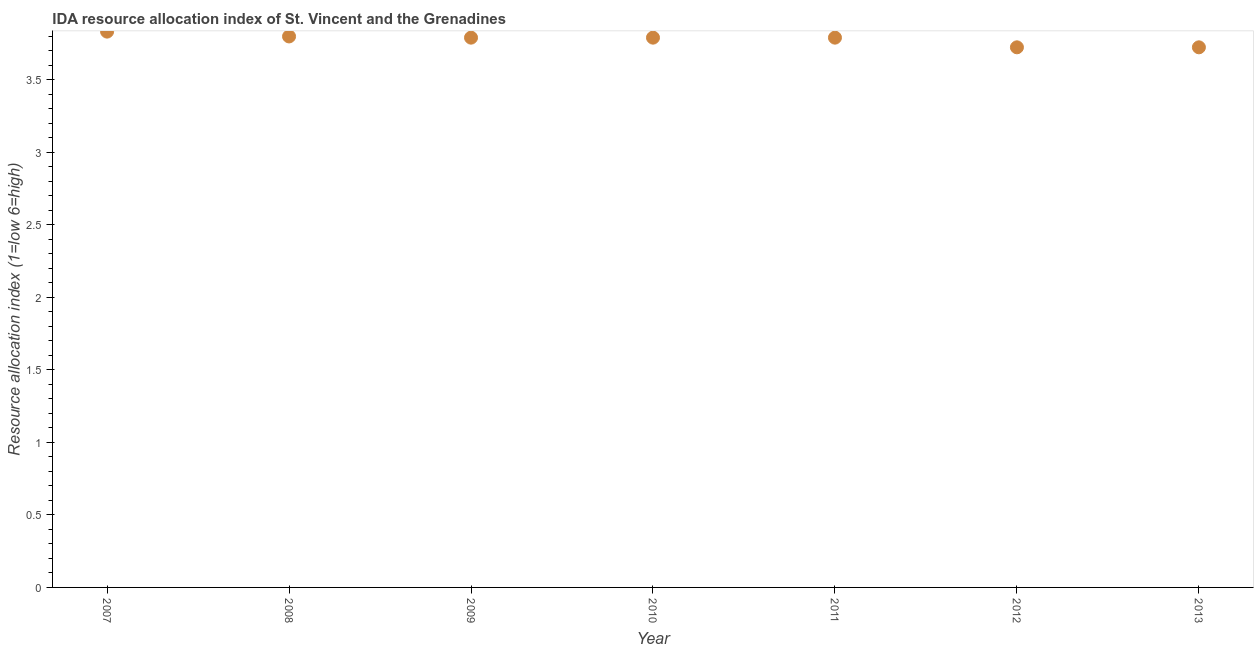What is the ida resource allocation index in 2010?
Your answer should be compact. 3.79. Across all years, what is the maximum ida resource allocation index?
Keep it short and to the point. 3.83. Across all years, what is the minimum ida resource allocation index?
Make the answer very short. 3.73. In which year was the ida resource allocation index maximum?
Offer a very short reply. 2007. In which year was the ida resource allocation index minimum?
Provide a succinct answer. 2012. What is the sum of the ida resource allocation index?
Offer a very short reply. 26.46. What is the difference between the ida resource allocation index in 2008 and 2009?
Your response must be concise. 0.01. What is the average ida resource allocation index per year?
Provide a short and direct response. 3.78. What is the median ida resource allocation index?
Provide a succinct answer. 3.79. Do a majority of the years between 2012 and 2010 (inclusive) have ida resource allocation index greater than 0.1 ?
Provide a short and direct response. No. What is the ratio of the ida resource allocation index in 2009 to that in 2012?
Your answer should be very brief. 1.02. What is the difference between the highest and the second highest ida resource allocation index?
Give a very brief answer. 0.03. What is the difference between the highest and the lowest ida resource allocation index?
Ensure brevity in your answer.  0.11. In how many years, is the ida resource allocation index greater than the average ida resource allocation index taken over all years?
Provide a succinct answer. 5. Does the ida resource allocation index monotonically increase over the years?
Keep it short and to the point. No. How many years are there in the graph?
Your answer should be very brief. 7. What is the difference between two consecutive major ticks on the Y-axis?
Your answer should be compact. 0.5. Does the graph contain any zero values?
Keep it short and to the point. No. Does the graph contain grids?
Your answer should be compact. No. What is the title of the graph?
Provide a short and direct response. IDA resource allocation index of St. Vincent and the Grenadines. What is the label or title of the Y-axis?
Keep it short and to the point. Resource allocation index (1=low 6=high). What is the Resource allocation index (1=low 6=high) in 2007?
Your response must be concise. 3.83. What is the Resource allocation index (1=low 6=high) in 2008?
Ensure brevity in your answer.  3.8. What is the Resource allocation index (1=low 6=high) in 2009?
Your answer should be very brief. 3.79. What is the Resource allocation index (1=low 6=high) in 2010?
Make the answer very short. 3.79. What is the Resource allocation index (1=low 6=high) in 2011?
Offer a very short reply. 3.79. What is the Resource allocation index (1=low 6=high) in 2012?
Your response must be concise. 3.73. What is the Resource allocation index (1=low 6=high) in 2013?
Your response must be concise. 3.73. What is the difference between the Resource allocation index (1=low 6=high) in 2007 and 2008?
Your answer should be compact. 0.03. What is the difference between the Resource allocation index (1=low 6=high) in 2007 and 2009?
Give a very brief answer. 0.04. What is the difference between the Resource allocation index (1=low 6=high) in 2007 and 2010?
Provide a short and direct response. 0.04. What is the difference between the Resource allocation index (1=low 6=high) in 2007 and 2011?
Your answer should be compact. 0.04. What is the difference between the Resource allocation index (1=low 6=high) in 2007 and 2012?
Make the answer very short. 0.11. What is the difference between the Resource allocation index (1=low 6=high) in 2007 and 2013?
Provide a succinct answer. 0.11. What is the difference between the Resource allocation index (1=low 6=high) in 2008 and 2009?
Provide a succinct answer. 0.01. What is the difference between the Resource allocation index (1=low 6=high) in 2008 and 2010?
Offer a terse response. 0.01. What is the difference between the Resource allocation index (1=low 6=high) in 2008 and 2011?
Make the answer very short. 0.01. What is the difference between the Resource allocation index (1=low 6=high) in 2008 and 2012?
Keep it short and to the point. 0.07. What is the difference between the Resource allocation index (1=low 6=high) in 2008 and 2013?
Make the answer very short. 0.07. What is the difference between the Resource allocation index (1=low 6=high) in 2009 and 2012?
Offer a very short reply. 0.07. What is the difference between the Resource allocation index (1=low 6=high) in 2009 and 2013?
Give a very brief answer. 0.07. What is the difference between the Resource allocation index (1=low 6=high) in 2010 and 2012?
Keep it short and to the point. 0.07. What is the difference between the Resource allocation index (1=low 6=high) in 2010 and 2013?
Your answer should be very brief. 0.07. What is the difference between the Resource allocation index (1=low 6=high) in 2011 and 2012?
Make the answer very short. 0.07. What is the difference between the Resource allocation index (1=low 6=high) in 2011 and 2013?
Your answer should be compact. 0.07. What is the difference between the Resource allocation index (1=low 6=high) in 2012 and 2013?
Ensure brevity in your answer.  0. What is the ratio of the Resource allocation index (1=low 6=high) in 2007 to that in 2008?
Offer a very short reply. 1.01. What is the ratio of the Resource allocation index (1=low 6=high) in 2007 to that in 2009?
Provide a succinct answer. 1.01. What is the ratio of the Resource allocation index (1=low 6=high) in 2007 to that in 2011?
Offer a very short reply. 1.01. What is the ratio of the Resource allocation index (1=low 6=high) in 2008 to that in 2012?
Offer a very short reply. 1.02. What is the ratio of the Resource allocation index (1=low 6=high) in 2008 to that in 2013?
Offer a very short reply. 1.02. What is the ratio of the Resource allocation index (1=low 6=high) in 2009 to that in 2010?
Your answer should be very brief. 1. What is the ratio of the Resource allocation index (1=low 6=high) in 2009 to that in 2012?
Provide a succinct answer. 1.02. What is the ratio of the Resource allocation index (1=low 6=high) in 2009 to that in 2013?
Keep it short and to the point. 1.02. What is the ratio of the Resource allocation index (1=low 6=high) in 2010 to that in 2011?
Offer a very short reply. 1. What is the ratio of the Resource allocation index (1=low 6=high) in 2011 to that in 2013?
Your answer should be compact. 1.02. 